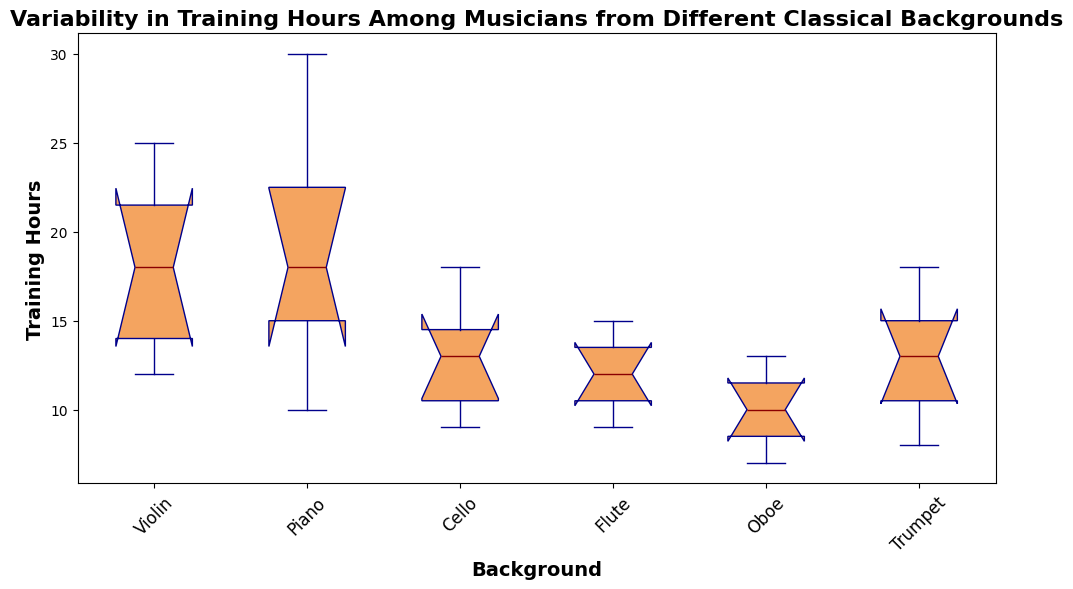What's the median Training Hours for Violinists? To find the median, list the Violin training hours in ascending order: 12, 13, 15, 18, 20, 23, 25. The median is the middle value in this list.
Answer: 18 Which instrument background has the smallest interquartile range (IQR) for Training Hours? The IQR is the difference between the 1st quartile (Q1) and the 3rd quartile (Q3). Visually compare the lengths of the boxes. The "Oboe" has the narrowest box, indicating it has the smallest IQR.
Answer: Oboe Among the Cello and Flute backgrounds, which has a higher median Training Hours? Locate the medians on the box plots. The median for Cello is 13.5 and for Flute is 11.5. Thus, Cello has a higher median.
Answer: Cello What is the range of Training Hours for the Trumpet background? The range is calculated by finding the difference between the maximum and minimum values. For Trumpet, the minimum training hours are 8 and the maximum is 18. Thus, the range is 18 - 8.
Answer: 10 Based on the visual attributes, which box plot has whiskers that extend the farthest? The whiskers represent the spread of the data outside the IQR. Visually compare the lengths of whiskers for each background. The "Piano" has the longest whiskers, indicating it extends the farthest.
Answer: Piano How do the median Training Hours for violinists and piano players compare? Compare the median lines of the Violin and Piano box plots. The median training hours for Violin is 18, while for Piano it is 16. Thus, Violin has a higher median.
Answer: Violin has a higher median Which instrument background shows the most variability in Training Hours? Variability can be assessed by looking at the range and the spread of the data. "Piano" shows the most variability as it has the widest spread of data points, indicated by the large box and the long whiskers.
Answer: Piano What's the minimum Training Hours observed across all backgrounds? Identify the lowest point across all box plots. The minimum observed training hours is for Oboe at 7 hours.
Answer: 7 